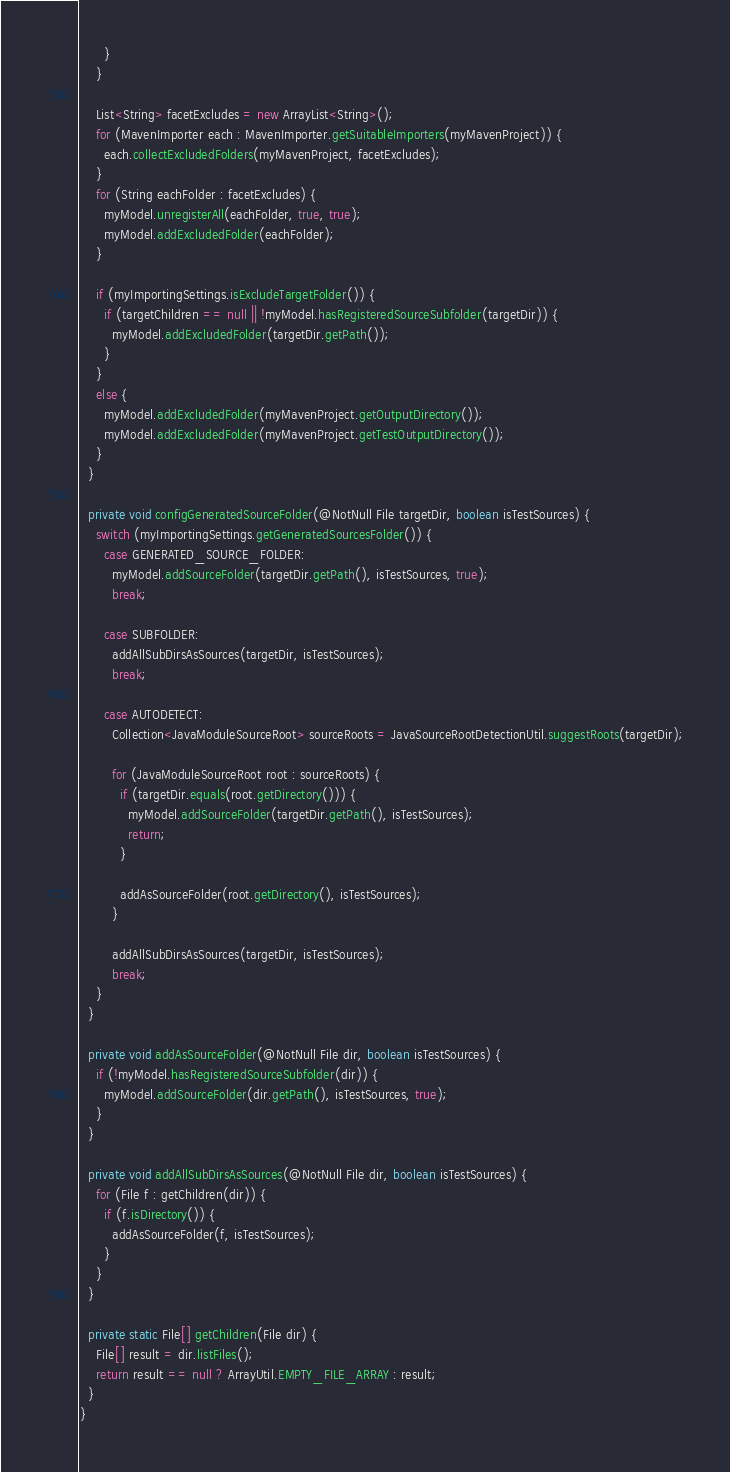<code> <loc_0><loc_0><loc_500><loc_500><_Java_>      }
    }

    List<String> facetExcludes = new ArrayList<String>();
    for (MavenImporter each : MavenImporter.getSuitableImporters(myMavenProject)) {
      each.collectExcludedFolders(myMavenProject, facetExcludes);
    }
    for (String eachFolder : facetExcludes) {
      myModel.unregisterAll(eachFolder, true, true);
      myModel.addExcludedFolder(eachFolder);
    }

    if (myImportingSettings.isExcludeTargetFolder()) {
      if (targetChildren == null || !myModel.hasRegisteredSourceSubfolder(targetDir)) {
        myModel.addExcludedFolder(targetDir.getPath());
      }
    }
    else {
      myModel.addExcludedFolder(myMavenProject.getOutputDirectory());
      myModel.addExcludedFolder(myMavenProject.getTestOutputDirectory());
    }
  }

  private void configGeneratedSourceFolder(@NotNull File targetDir, boolean isTestSources) {
    switch (myImportingSettings.getGeneratedSourcesFolder()) {
      case GENERATED_SOURCE_FOLDER:
        myModel.addSourceFolder(targetDir.getPath(), isTestSources, true);
        break;

      case SUBFOLDER:
        addAllSubDirsAsSources(targetDir, isTestSources);
        break;

      case AUTODETECT:
        Collection<JavaModuleSourceRoot> sourceRoots = JavaSourceRootDetectionUtil.suggestRoots(targetDir);

        for (JavaModuleSourceRoot root : sourceRoots) {
          if (targetDir.equals(root.getDirectory())) {
            myModel.addSourceFolder(targetDir.getPath(), isTestSources);
            return;
          }

          addAsSourceFolder(root.getDirectory(), isTestSources);
        }

        addAllSubDirsAsSources(targetDir, isTestSources);
        break;
    }
  }

  private void addAsSourceFolder(@NotNull File dir, boolean isTestSources) {
    if (!myModel.hasRegisteredSourceSubfolder(dir)) {
      myModel.addSourceFolder(dir.getPath(), isTestSources, true);
    }
  }

  private void addAllSubDirsAsSources(@NotNull File dir, boolean isTestSources) {
    for (File f : getChildren(dir)) {
      if (f.isDirectory()) {
        addAsSourceFolder(f, isTestSources);
      }
    }
  }

  private static File[] getChildren(File dir) {
    File[] result = dir.listFiles();
    return result == null ? ArrayUtil.EMPTY_FILE_ARRAY : result;
  }
}
</code> 